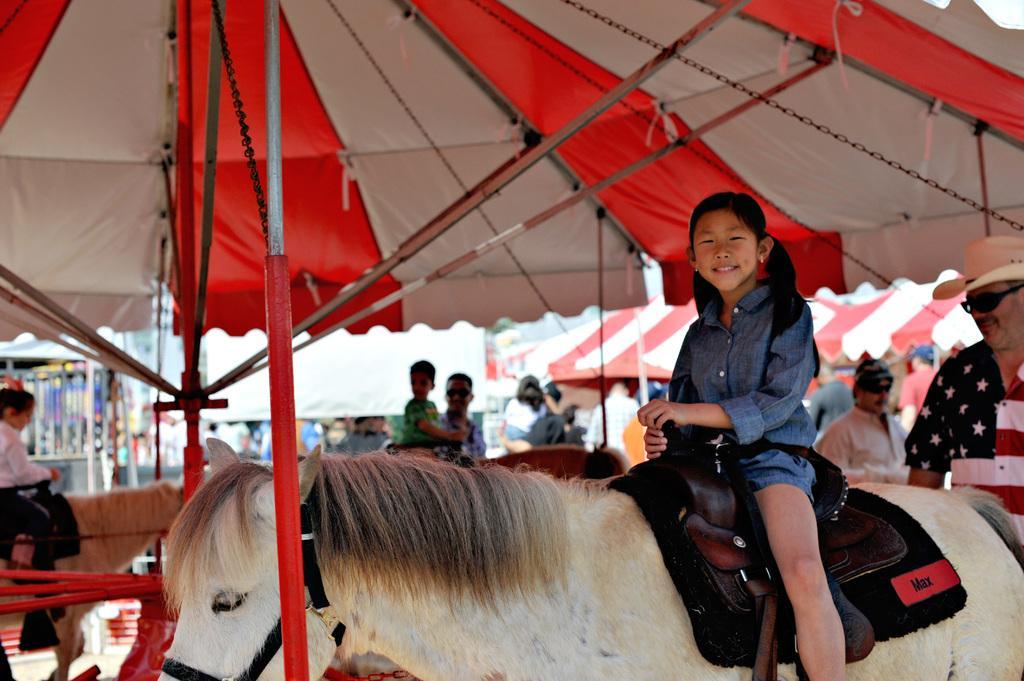Describe this image in one or two sentences. In this image, There is a horse which is in white color on that horse there is a girl sitting and in the backdrop the is a shed which is in white and red color, There are some people standing. 